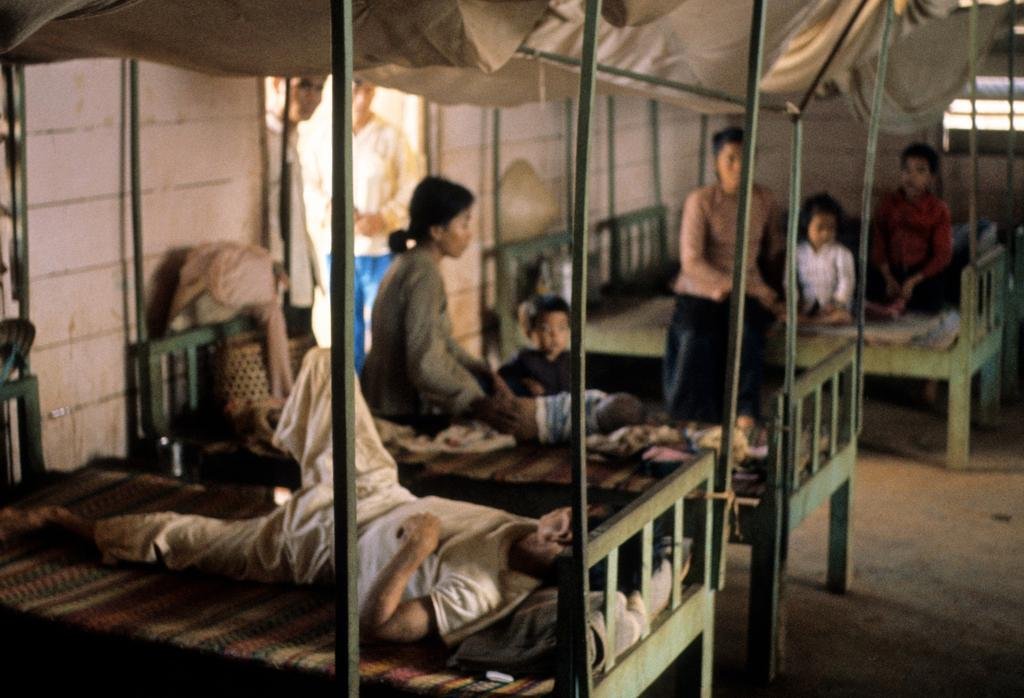What type of furniture is present in the image? There are beds in the image. What are some people doing on the beds? Some people are sitting on the beds, while others are lying on the beds. Are there any people standing in the image? Yes, there are people standing in the image. What type of fowl can be seen in the image? There is no fowl present in the image; it features beds with people sitting, lying, and standing. 